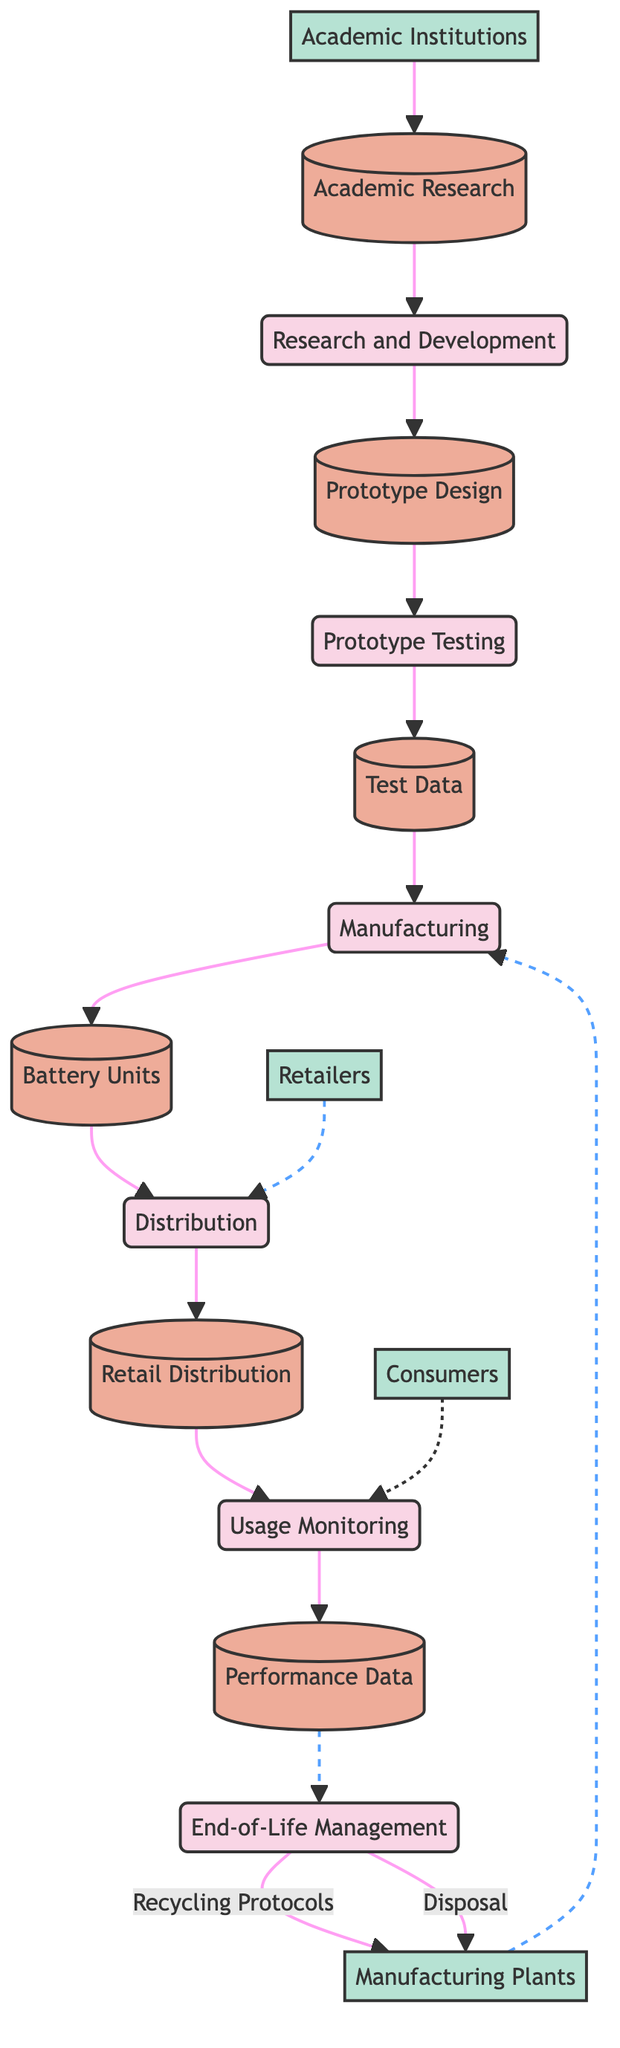What are the inputs for the Prototype Testing process? The inputs for the Prototype Testing process are indicated as the outputs from the previous process, which is "Prototype Design". From the diagram, we can see that "Prototype Design" feeds into the "Prototype Testing" process.
Answer: Prototype Design How many external entities are present in the diagram? The diagram includes four external entities: "Academic Institutions", "Manufacturing Plants", "Retailers", and "Consumers". We count each entity represented outside the main flow of processes.
Answer: 4 What outputs does the End-of-Life Management process produce? The outputs from the End-of-Life Management process can be traced as they stem from Performance Data and lead to the recycling protocols and disposal. This information is shown where the arrows from End-of-Life Management are directed towards the external entity Manufacturing Plants.
Answer: Recycling Protocols, Disposal Which process follows the Manufacturing process? To determine the sequence, we observe the flow of outputs and inputs. The Manufacturing process outputs "Battery Units", which then serve as inputs to the subsequent process identified as "Distribution". Thus, the process that follows Manufacturing is Distribution.
Answer: Distribution Which external entity provides input to the Research and Development process? The input to the Research and Development process is from "Academic Research", which is represented as being linked to the external entity "Academic Institutions". This indicates that academic research is the foundational input for the initial process.
Answer: Academic Institutions What type of data store is "Retail Distribution"? The diagram designates "Retail Distribution" as a type of data store. It is labeled under the category of "Distribution Records", giving specific context about the type of information stored there.
Answer: Distribution Records How many processes are connected to the Consumers entity? To find how many processes connect to the Consumers entity, we look for the arrows directed towards Consumers. The only direct connection is from the Usage Monitoring process, which indicates that it is the only process summarized in relation to consumers within the lifecycle management framework.
Answer: 1 Which process generates Test Data? The generation of Test Data is derived from the Prototype Testing process, where inputs from Prototype Design are evaluated, leading to the creation of Test Data through this testing phase. Thus, the role of generating Test Data is performed by Prototype Testing.
Answer: Prototype Testing What is the final output of the entire diagram's flow? The final output from the process flow of the diagram is achieved from the End-of-Life Management, which delivers the outputs of Recycling Protocols and Disposal, marking the closure of the battery lifecycle management process.
Answer: Recycling Protocols, Disposal 